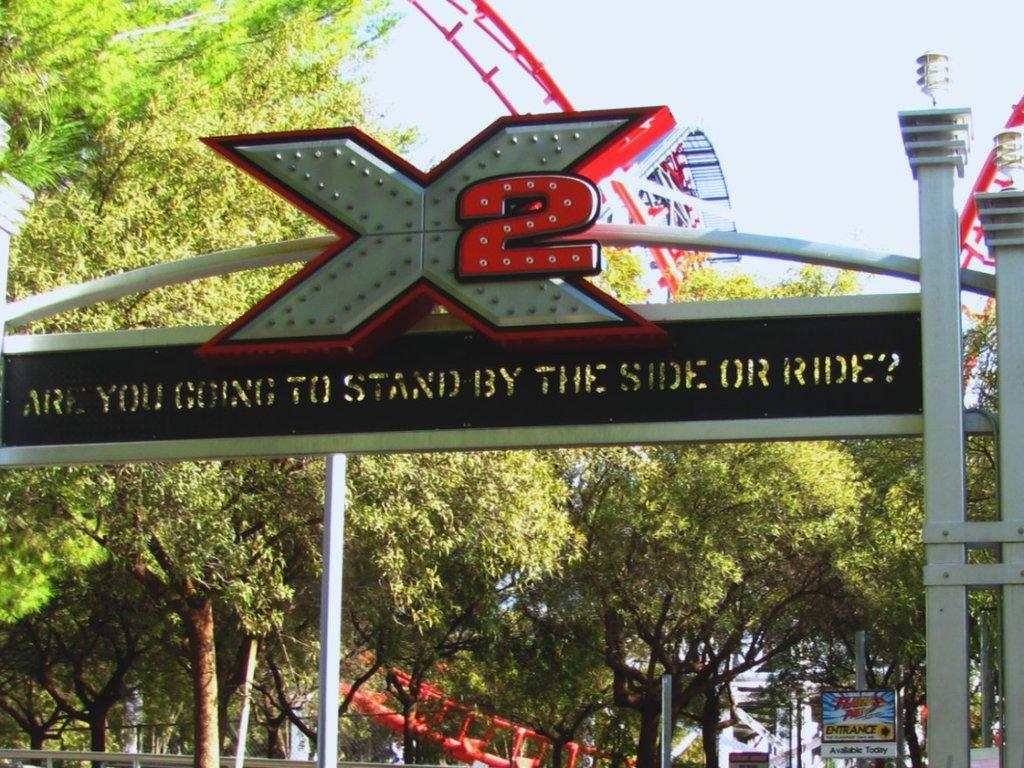What is the main object in the image? There is a name board in the image. What other objects can be seen in the image? There are poles, boards, trees, and a roller coaster visible in the image. What is the background of the image? The background of the image includes trees and the sky. What type of metal is used to construct the acoustics in the image? There is no mention of acoustics or metal in the image; it primarily features a name board, poles, boards, trees, and a roller coaster. 